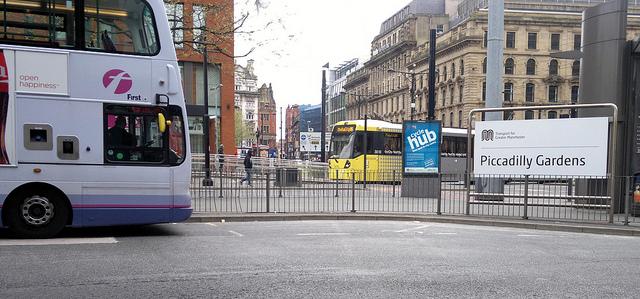What does the sign say?
Answer briefly. Piccadilly gardens. How many buses are there?
Write a very short answer. 2. How many buses?
Concise answer only. 2. What is advertised?
Answer briefly. Piccadilly gardens. Is the vehicle on the left a bus?
Answer briefly. Yes. What country is this?
Be succinct. Usa. Is the bus in a parking lot?
Write a very short answer. Yes. Does there seem to be a designated area for the food trucks?
Short answer required. No. How many buses are in the picture?
Give a very brief answer. 2. What does the street sign say?
Give a very brief answer. Piccadilly gardens. 